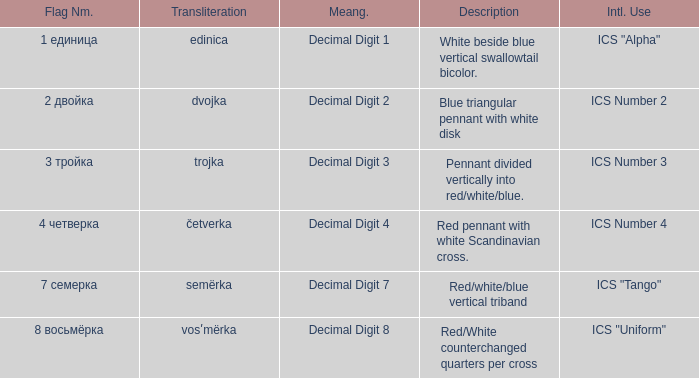What are the meanings of the flag whose name transliterates to semërka? Decimal Digit 7. 